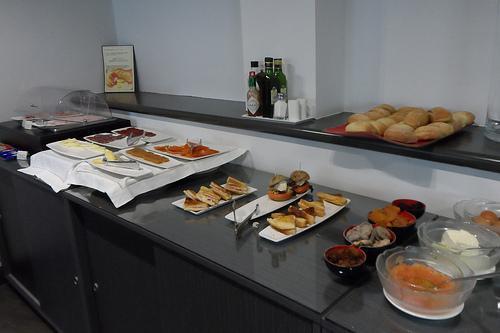How many bowls on the right?
Give a very brief answer. 3. How many bottles are on the shelf?
Give a very brief answer. 4. How many clear bowls?
Give a very brief answer. 3. 